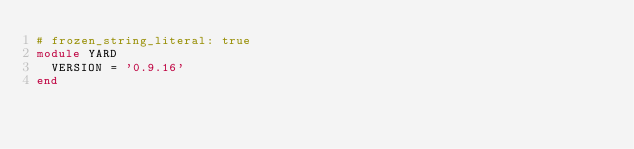Convert code to text. <code><loc_0><loc_0><loc_500><loc_500><_Ruby_># frozen_string_literal: true
module YARD
  VERSION = '0.9.16'
end
</code> 